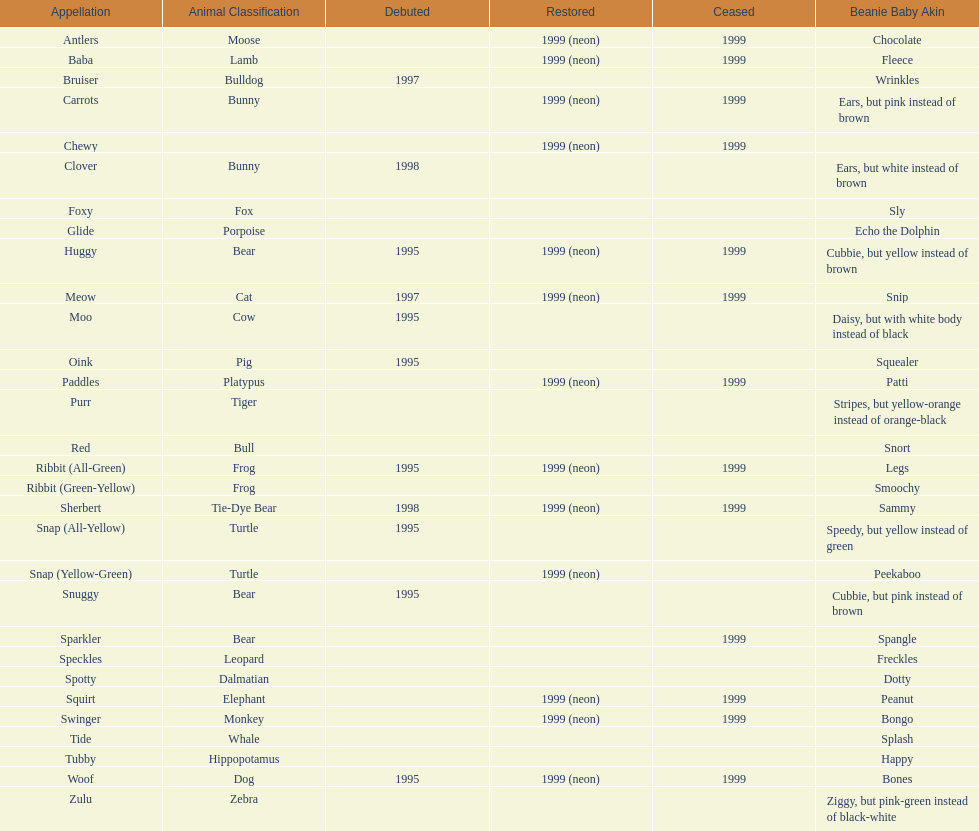What is the name of the last pillow pal on this chart? Zulu. 